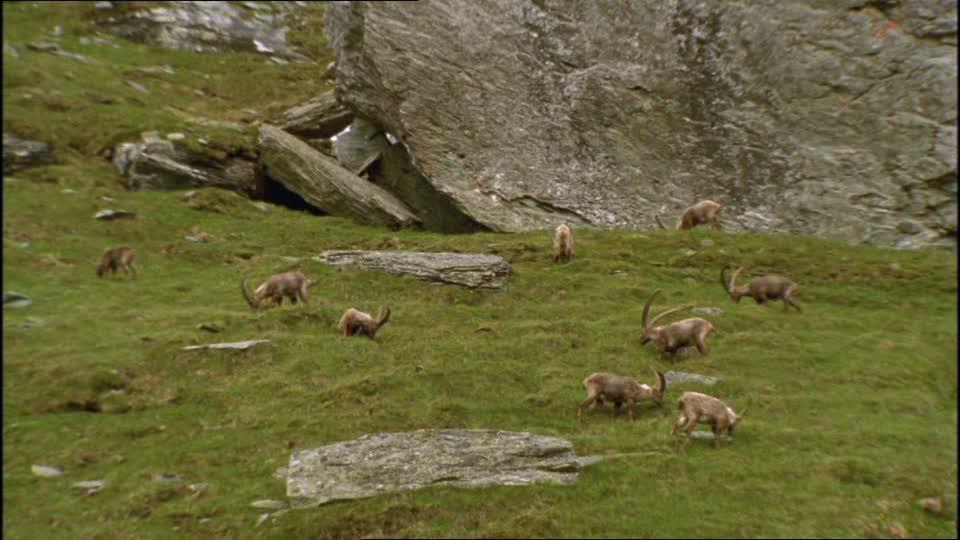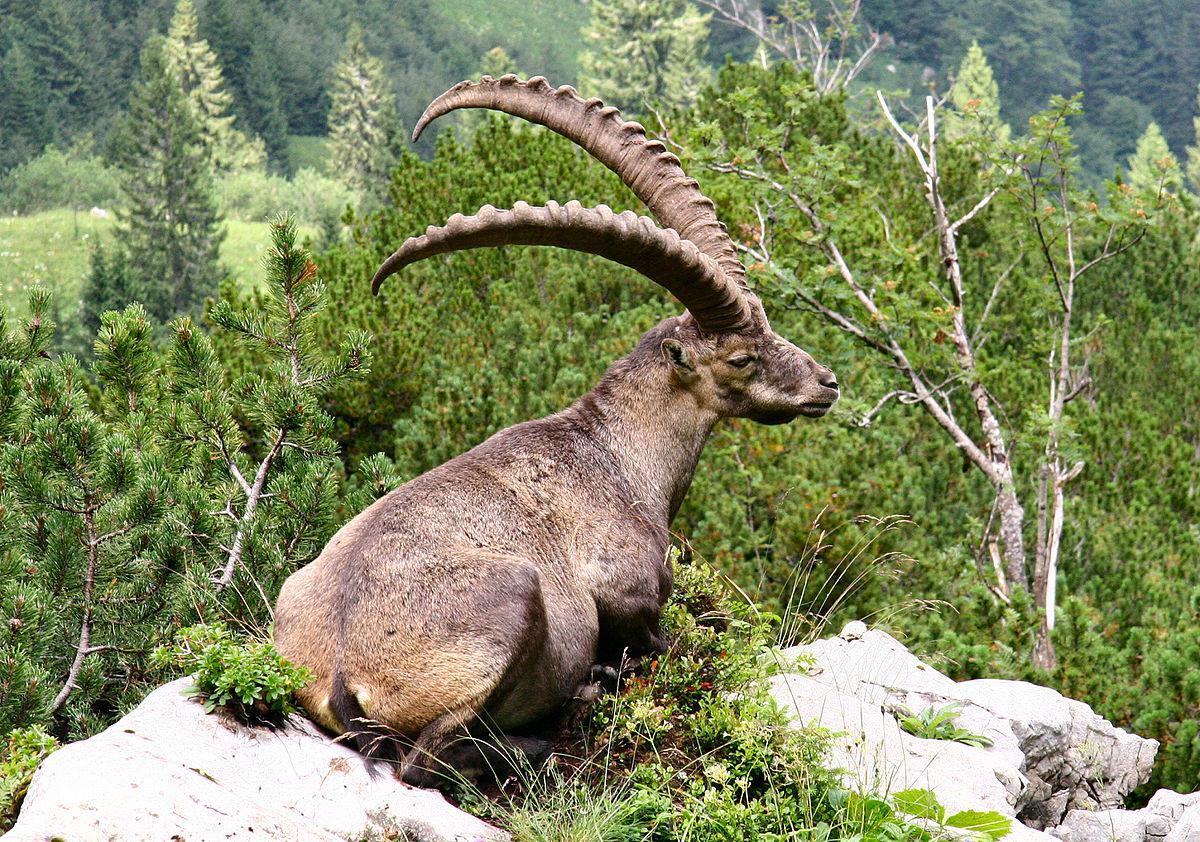The first image is the image on the left, the second image is the image on the right. Given the left and right images, does the statement "Each imagine is one animal facing to the right" hold true? Answer yes or no. No. The first image is the image on the left, the second image is the image on the right. For the images displayed, is the sentence "The right image shows a ram next to rocks." factually correct? Answer yes or no. Yes. 